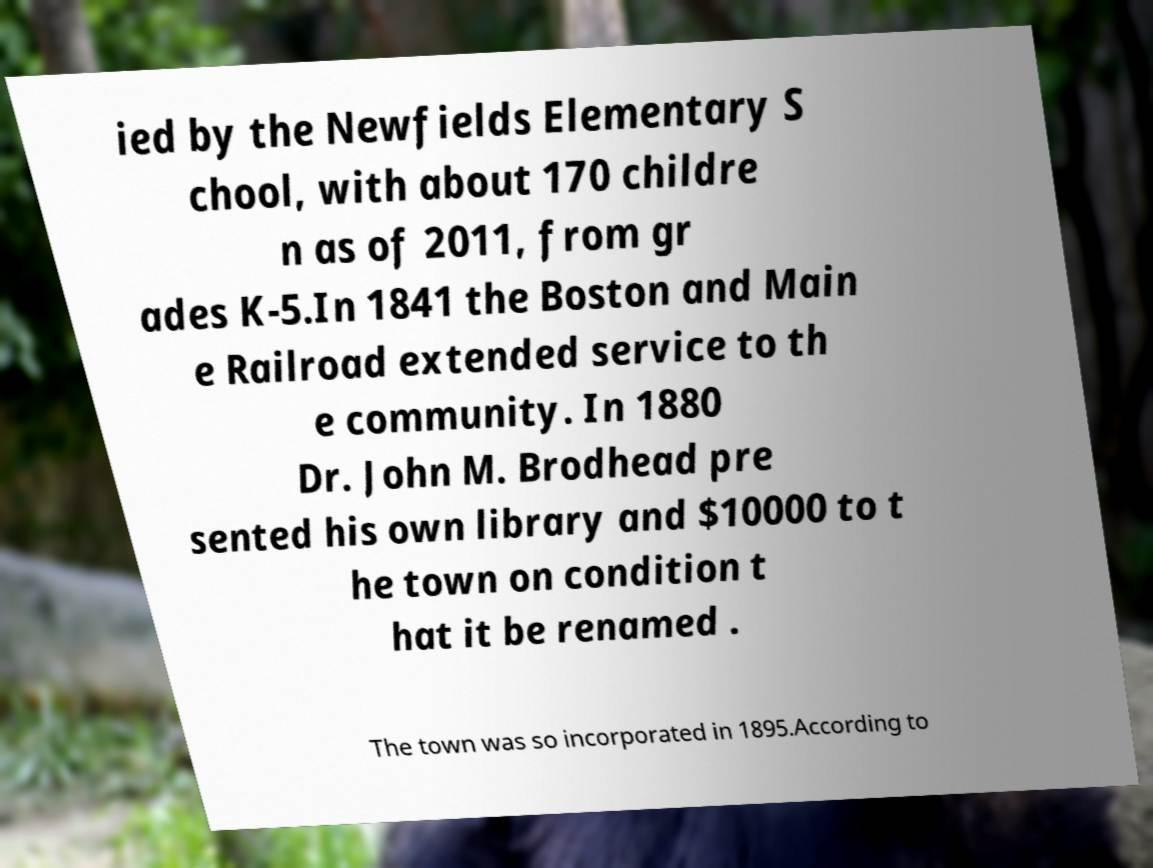What messages or text are displayed in this image? I need them in a readable, typed format. ied by the Newfields Elementary S chool, with about 170 childre n as of 2011, from gr ades K-5.In 1841 the Boston and Main e Railroad extended service to th e community. In 1880 Dr. John M. Brodhead pre sented his own library and $10000 to t he town on condition t hat it be renamed . The town was so incorporated in 1895.According to 